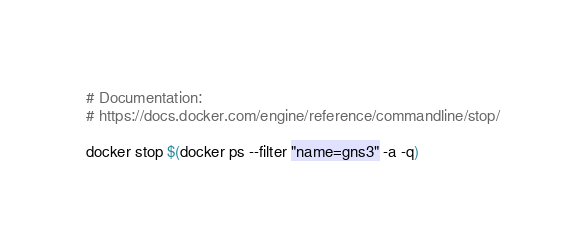<code> <loc_0><loc_0><loc_500><loc_500><_Bash_># Documentation:
# https://docs.docker.com/engine/reference/commandline/stop/

docker stop $(docker ps --filter "name=gns3" -a -q)
</code> 